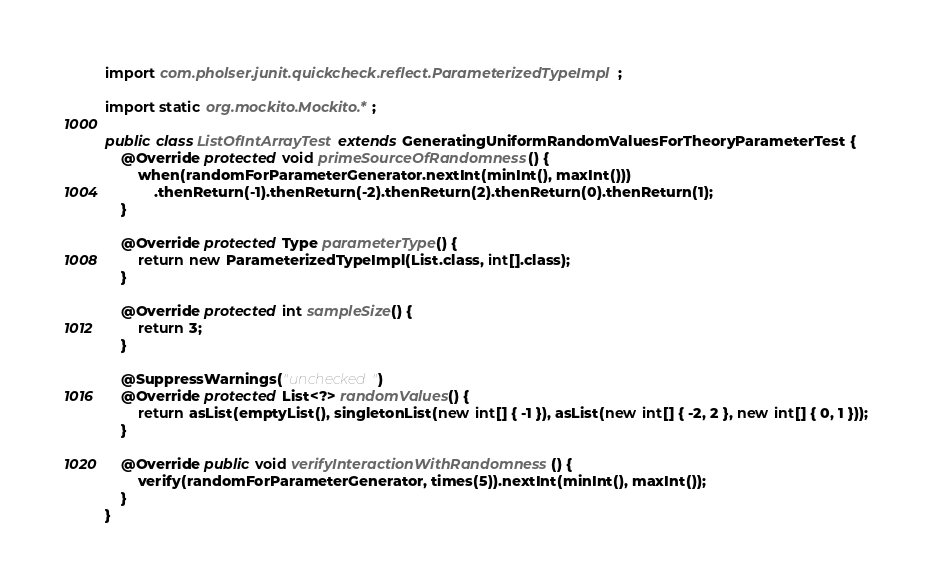Convert code to text. <code><loc_0><loc_0><loc_500><loc_500><_Java_>import com.pholser.junit.quickcheck.reflect.ParameterizedTypeImpl;

import static org.mockito.Mockito.*;

public class ListOfIntArrayTest extends GeneratingUniformRandomValuesForTheoryParameterTest {
    @Override protected void primeSourceOfRandomness() {
        when(randomForParameterGenerator.nextInt(minInt(), maxInt()))
            .thenReturn(-1).thenReturn(-2).thenReturn(2).thenReturn(0).thenReturn(1);
    }

    @Override protected Type parameterType() {
        return new ParameterizedTypeImpl(List.class, int[].class);
    }

    @Override protected int sampleSize() {
        return 3;
    }

    @SuppressWarnings("unchecked")
    @Override protected List<?> randomValues() {
        return asList(emptyList(), singletonList(new int[] { -1 }), asList(new int[] { -2, 2 }, new int[] { 0, 1 }));
    }

    @Override public void verifyInteractionWithRandomness() {
        verify(randomForParameterGenerator, times(5)).nextInt(minInt(), maxInt());
    }
}
</code> 